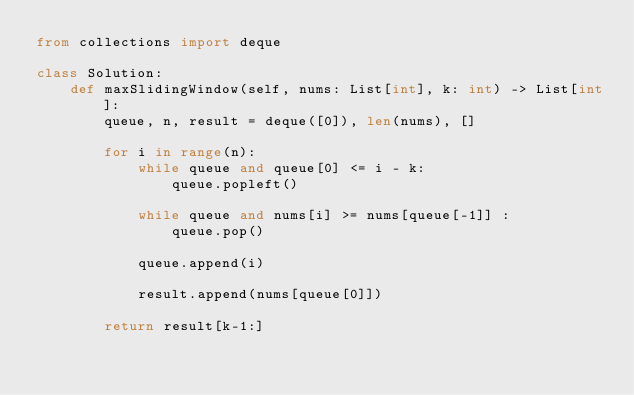Convert code to text. <code><loc_0><loc_0><loc_500><loc_500><_Python_>from collections import deque

class Solution:
    def maxSlidingWindow(self, nums: List[int], k: int) -> List[int]:
        queue, n, result = deque([0]), len(nums), []

        for i in range(n):
            while queue and queue[0] <= i - k:
                queue.popleft()
            
            while queue and nums[i] >= nums[queue[-1]] :
                queue.pop()
            
            queue.append(i)
            
            result.append(nums[queue[0]])
            
        return result[k-1:]</code> 